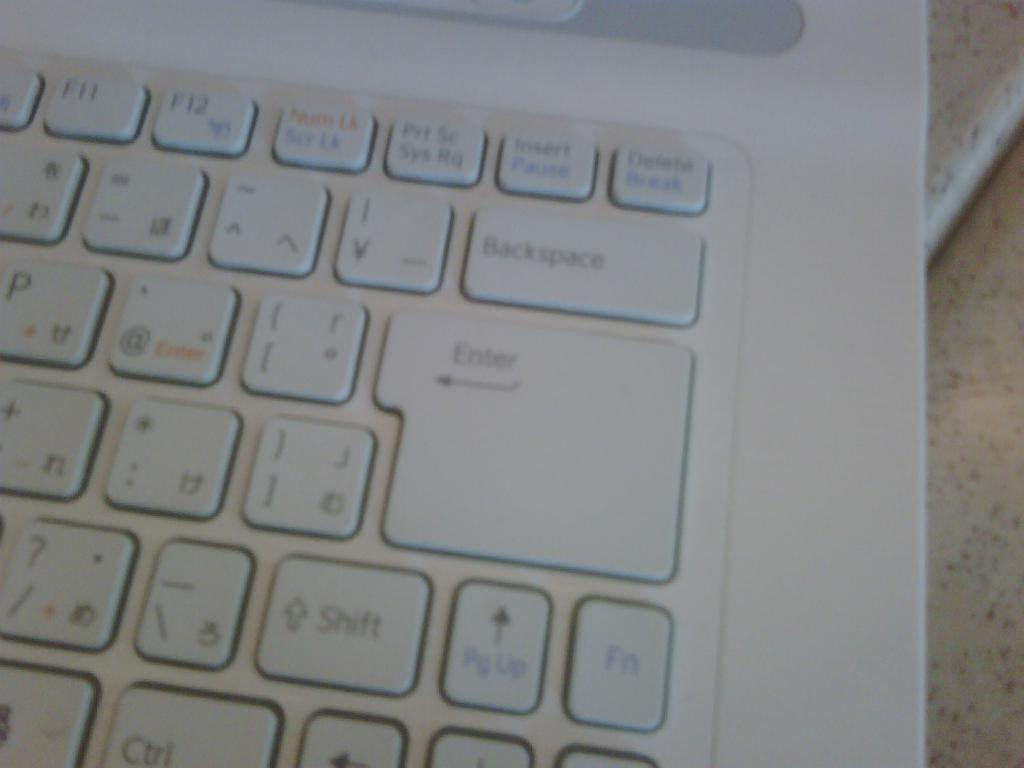<image>
Summarize the visual content of the image. The enter key on the keyboard is two rows tall. 